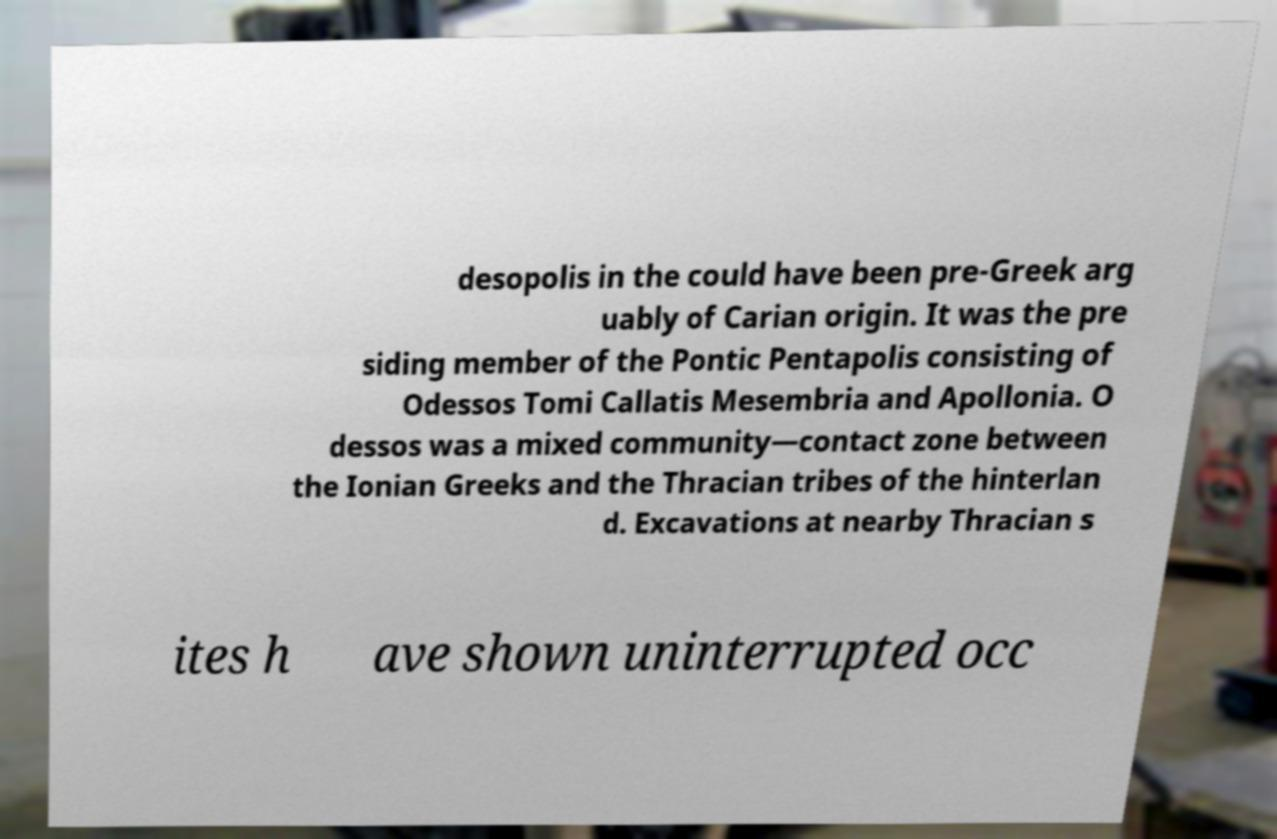Could you extract and type out the text from this image? desopolis in the could have been pre-Greek arg uably of Carian origin. It was the pre siding member of the Pontic Pentapolis consisting of Odessos Tomi Callatis Mesembria and Apollonia. O dessos was a mixed community—contact zone between the Ionian Greeks and the Thracian tribes of the hinterlan d. Excavations at nearby Thracian s ites h ave shown uninterrupted occ 